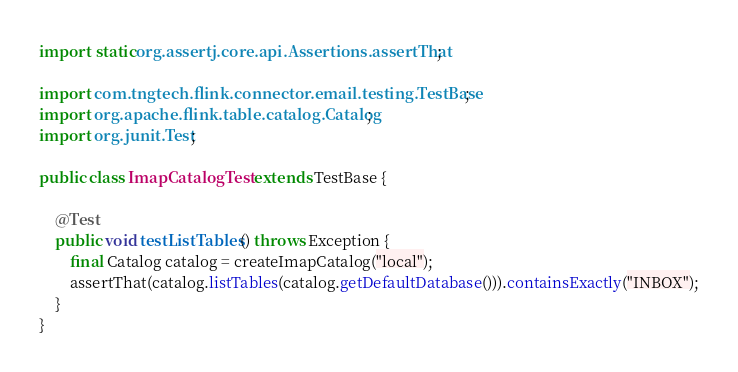Convert code to text. <code><loc_0><loc_0><loc_500><loc_500><_Java_>import static org.assertj.core.api.Assertions.assertThat;

import com.tngtech.flink.connector.email.testing.TestBase;
import org.apache.flink.table.catalog.Catalog;
import org.junit.Test;

public class ImapCatalogTest extends TestBase {

    @Test
    public void testListTables() throws Exception {
        final Catalog catalog = createImapCatalog("local");
        assertThat(catalog.listTables(catalog.getDefaultDatabase())).containsExactly("INBOX");
    }
}
</code> 